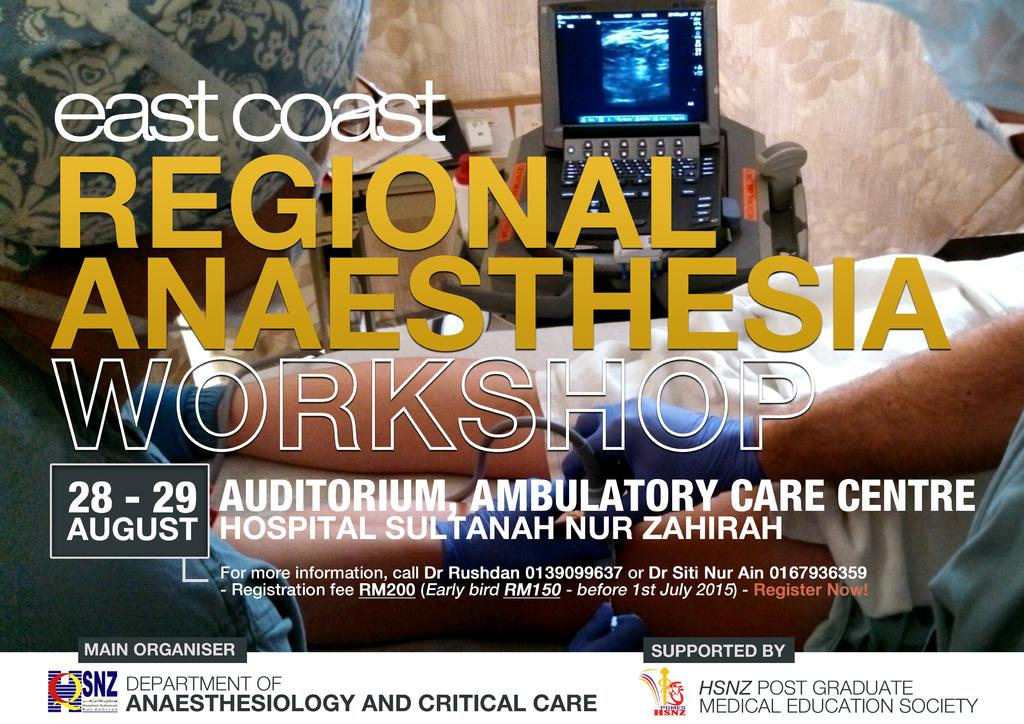Provide a one-sentence caption for the provided image. An advertisement for a regional anaesthesia office showing a doctor putting a syringe in a patient. 